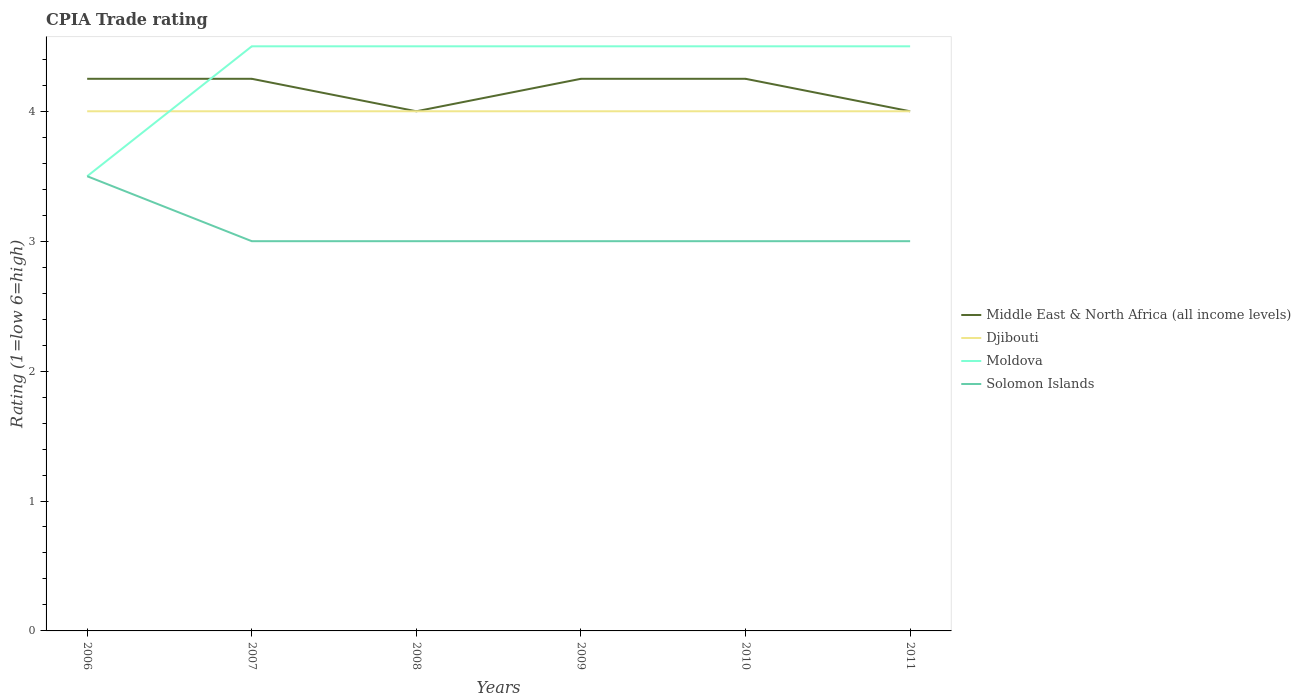Is the number of lines equal to the number of legend labels?
Offer a very short reply. Yes. In which year was the CPIA rating in Moldova maximum?
Provide a short and direct response. 2006. What is the difference between the highest and the second highest CPIA rating in Solomon Islands?
Your answer should be very brief. 0.5. Is the CPIA rating in Moldova strictly greater than the CPIA rating in Djibouti over the years?
Keep it short and to the point. No. Does the graph contain any zero values?
Provide a short and direct response. No. How many legend labels are there?
Give a very brief answer. 4. What is the title of the graph?
Make the answer very short. CPIA Trade rating. Does "European Union" appear as one of the legend labels in the graph?
Provide a short and direct response. No. What is the label or title of the X-axis?
Make the answer very short. Years. What is the Rating (1=low 6=high) in Middle East & North Africa (all income levels) in 2006?
Give a very brief answer. 4.25. What is the Rating (1=low 6=high) of Moldova in 2006?
Provide a succinct answer. 3.5. What is the Rating (1=low 6=high) in Solomon Islands in 2006?
Ensure brevity in your answer.  3.5. What is the Rating (1=low 6=high) in Middle East & North Africa (all income levels) in 2007?
Give a very brief answer. 4.25. What is the Rating (1=low 6=high) of Djibouti in 2007?
Give a very brief answer. 4. What is the Rating (1=low 6=high) in Middle East & North Africa (all income levels) in 2008?
Ensure brevity in your answer.  4. What is the Rating (1=low 6=high) in Middle East & North Africa (all income levels) in 2009?
Ensure brevity in your answer.  4.25. What is the Rating (1=low 6=high) in Djibouti in 2009?
Give a very brief answer. 4. What is the Rating (1=low 6=high) of Middle East & North Africa (all income levels) in 2010?
Provide a succinct answer. 4.25. What is the Rating (1=low 6=high) in Solomon Islands in 2010?
Offer a very short reply. 3. What is the Rating (1=low 6=high) in Djibouti in 2011?
Make the answer very short. 4. Across all years, what is the maximum Rating (1=low 6=high) in Middle East & North Africa (all income levels)?
Offer a terse response. 4.25. Across all years, what is the maximum Rating (1=low 6=high) in Solomon Islands?
Offer a terse response. 3.5. Across all years, what is the minimum Rating (1=low 6=high) of Middle East & North Africa (all income levels)?
Make the answer very short. 4. Across all years, what is the minimum Rating (1=low 6=high) in Djibouti?
Make the answer very short. 4. Across all years, what is the minimum Rating (1=low 6=high) in Moldova?
Ensure brevity in your answer.  3.5. What is the total Rating (1=low 6=high) in Middle East & North Africa (all income levels) in the graph?
Offer a very short reply. 25. What is the total Rating (1=low 6=high) in Moldova in the graph?
Your answer should be compact. 26. What is the total Rating (1=low 6=high) of Solomon Islands in the graph?
Your response must be concise. 18.5. What is the difference between the Rating (1=low 6=high) of Djibouti in 2006 and that in 2007?
Your answer should be compact. 0. What is the difference between the Rating (1=low 6=high) in Moldova in 2006 and that in 2007?
Make the answer very short. -1. What is the difference between the Rating (1=low 6=high) of Solomon Islands in 2006 and that in 2007?
Your answer should be very brief. 0.5. What is the difference between the Rating (1=low 6=high) of Middle East & North Africa (all income levels) in 2006 and that in 2008?
Your answer should be very brief. 0.25. What is the difference between the Rating (1=low 6=high) in Djibouti in 2006 and that in 2008?
Your response must be concise. 0. What is the difference between the Rating (1=low 6=high) of Moldova in 2006 and that in 2008?
Ensure brevity in your answer.  -1. What is the difference between the Rating (1=low 6=high) of Solomon Islands in 2006 and that in 2009?
Offer a very short reply. 0.5. What is the difference between the Rating (1=low 6=high) of Moldova in 2006 and that in 2010?
Your response must be concise. -1. What is the difference between the Rating (1=low 6=high) of Solomon Islands in 2006 and that in 2010?
Offer a terse response. 0.5. What is the difference between the Rating (1=low 6=high) in Moldova in 2006 and that in 2011?
Ensure brevity in your answer.  -1. What is the difference between the Rating (1=low 6=high) of Solomon Islands in 2006 and that in 2011?
Make the answer very short. 0.5. What is the difference between the Rating (1=low 6=high) in Middle East & North Africa (all income levels) in 2007 and that in 2008?
Keep it short and to the point. 0.25. What is the difference between the Rating (1=low 6=high) in Djibouti in 2007 and that in 2008?
Offer a terse response. 0. What is the difference between the Rating (1=low 6=high) of Moldova in 2007 and that in 2008?
Ensure brevity in your answer.  0. What is the difference between the Rating (1=low 6=high) of Middle East & North Africa (all income levels) in 2007 and that in 2009?
Give a very brief answer. 0. What is the difference between the Rating (1=low 6=high) of Djibouti in 2007 and that in 2009?
Your answer should be compact. 0. What is the difference between the Rating (1=low 6=high) in Middle East & North Africa (all income levels) in 2007 and that in 2010?
Your answer should be very brief. 0. What is the difference between the Rating (1=low 6=high) of Djibouti in 2007 and that in 2010?
Offer a very short reply. 0. What is the difference between the Rating (1=low 6=high) of Djibouti in 2007 and that in 2011?
Your answer should be very brief. 0. What is the difference between the Rating (1=low 6=high) of Moldova in 2007 and that in 2011?
Your answer should be compact. 0. What is the difference between the Rating (1=low 6=high) of Solomon Islands in 2007 and that in 2011?
Your answer should be very brief. 0. What is the difference between the Rating (1=low 6=high) in Middle East & North Africa (all income levels) in 2008 and that in 2009?
Your response must be concise. -0.25. What is the difference between the Rating (1=low 6=high) in Moldova in 2008 and that in 2009?
Offer a very short reply. 0. What is the difference between the Rating (1=low 6=high) in Middle East & North Africa (all income levels) in 2008 and that in 2010?
Your answer should be very brief. -0.25. What is the difference between the Rating (1=low 6=high) in Djibouti in 2008 and that in 2010?
Ensure brevity in your answer.  0. What is the difference between the Rating (1=low 6=high) of Moldova in 2008 and that in 2010?
Provide a short and direct response. 0. What is the difference between the Rating (1=low 6=high) of Solomon Islands in 2008 and that in 2010?
Your answer should be compact. 0. What is the difference between the Rating (1=low 6=high) in Middle East & North Africa (all income levels) in 2008 and that in 2011?
Keep it short and to the point. 0. What is the difference between the Rating (1=low 6=high) in Solomon Islands in 2008 and that in 2011?
Offer a terse response. 0. What is the difference between the Rating (1=low 6=high) in Middle East & North Africa (all income levels) in 2009 and that in 2010?
Give a very brief answer. 0. What is the difference between the Rating (1=low 6=high) in Moldova in 2009 and that in 2010?
Give a very brief answer. 0. What is the difference between the Rating (1=low 6=high) in Solomon Islands in 2009 and that in 2010?
Your answer should be very brief. 0. What is the difference between the Rating (1=low 6=high) in Middle East & North Africa (all income levels) in 2009 and that in 2011?
Your answer should be very brief. 0.25. What is the difference between the Rating (1=low 6=high) of Djibouti in 2009 and that in 2011?
Provide a succinct answer. 0. What is the difference between the Rating (1=low 6=high) of Moldova in 2009 and that in 2011?
Offer a terse response. 0. What is the difference between the Rating (1=low 6=high) of Solomon Islands in 2010 and that in 2011?
Give a very brief answer. 0. What is the difference between the Rating (1=low 6=high) of Middle East & North Africa (all income levels) in 2006 and the Rating (1=low 6=high) of Djibouti in 2007?
Provide a short and direct response. 0.25. What is the difference between the Rating (1=low 6=high) in Middle East & North Africa (all income levels) in 2006 and the Rating (1=low 6=high) in Solomon Islands in 2007?
Give a very brief answer. 1.25. What is the difference between the Rating (1=low 6=high) in Moldova in 2006 and the Rating (1=low 6=high) in Solomon Islands in 2007?
Offer a terse response. 0.5. What is the difference between the Rating (1=low 6=high) in Middle East & North Africa (all income levels) in 2006 and the Rating (1=low 6=high) in Moldova in 2008?
Provide a succinct answer. -0.25. What is the difference between the Rating (1=low 6=high) in Middle East & North Africa (all income levels) in 2006 and the Rating (1=low 6=high) in Solomon Islands in 2008?
Provide a short and direct response. 1.25. What is the difference between the Rating (1=low 6=high) in Moldova in 2006 and the Rating (1=low 6=high) in Solomon Islands in 2008?
Your response must be concise. 0.5. What is the difference between the Rating (1=low 6=high) in Djibouti in 2006 and the Rating (1=low 6=high) in Moldova in 2009?
Offer a very short reply. -0.5. What is the difference between the Rating (1=low 6=high) in Middle East & North Africa (all income levels) in 2006 and the Rating (1=low 6=high) in Djibouti in 2010?
Offer a very short reply. 0.25. What is the difference between the Rating (1=low 6=high) of Djibouti in 2006 and the Rating (1=low 6=high) of Moldova in 2010?
Ensure brevity in your answer.  -0.5. What is the difference between the Rating (1=low 6=high) in Moldova in 2006 and the Rating (1=low 6=high) in Solomon Islands in 2010?
Make the answer very short. 0.5. What is the difference between the Rating (1=low 6=high) of Middle East & North Africa (all income levels) in 2006 and the Rating (1=low 6=high) of Djibouti in 2011?
Your answer should be compact. 0.25. What is the difference between the Rating (1=low 6=high) in Djibouti in 2006 and the Rating (1=low 6=high) in Moldova in 2011?
Offer a very short reply. -0.5. What is the difference between the Rating (1=low 6=high) in Djibouti in 2006 and the Rating (1=low 6=high) in Solomon Islands in 2011?
Provide a succinct answer. 1. What is the difference between the Rating (1=low 6=high) of Moldova in 2006 and the Rating (1=low 6=high) of Solomon Islands in 2011?
Give a very brief answer. 0.5. What is the difference between the Rating (1=low 6=high) of Middle East & North Africa (all income levels) in 2007 and the Rating (1=low 6=high) of Solomon Islands in 2009?
Your answer should be compact. 1.25. What is the difference between the Rating (1=low 6=high) of Djibouti in 2007 and the Rating (1=low 6=high) of Solomon Islands in 2009?
Keep it short and to the point. 1. What is the difference between the Rating (1=low 6=high) of Middle East & North Africa (all income levels) in 2007 and the Rating (1=low 6=high) of Djibouti in 2010?
Give a very brief answer. 0.25. What is the difference between the Rating (1=low 6=high) in Middle East & North Africa (all income levels) in 2007 and the Rating (1=low 6=high) in Solomon Islands in 2010?
Provide a short and direct response. 1.25. What is the difference between the Rating (1=low 6=high) in Djibouti in 2007 and the Rating (1=low 6=high) in Moldova in 2010?
Provide a short and direct response. -0.5. What is the difference between the Rating (1=low 6=high) in Moldova in 2007 and the Rating (1=low 6=high) in Solomon Islands in 2010?
Your answer should be compact. 1.5. What is the difference between the Rating (1=low 6=high) of Djibouti in 2007 and the Rating (1=low 6=high) of Solomon Islands in 2011?
Offer a terse response. 1. What is the difference between the Rating (1=low 6=high) of Moldova in 2007 and the Rating (1=low 6=high) of Solomon Islands in 2011?
Provide a short and direct response. 1.5. What is the difference between the Rating (1=low 6=high) in Middle East & North Africa (all income levels) in 2008 and the Rating (1=low 6=high) in Moldova in 2009?
Give a very brief answer. -0.5. What is the difference between the Rating (1=low 6=high) in Moldova in 2008 and the Rating (1=low 6=high) in Solomon Islands in 2009?
Make the answer very short. 1.5. What is the difference between the Rating (1=low 6=high) in Middle East & North Africa (all income levels) in 2008 and the Rating (1=low 6=high) in Moldova in 2010?
Offer a terse response. -0.5. What is the difference between the Rating (1=low 6=high) in Middle East & North Africa (all income levels) in 2008 and the Rating (1=low 6=high) in Solomon Islands in 2010?
Your answer should be compact. 1. What is the difference between the Rating (1=low 6=high) of Djibouti in 2008 and the Rating (1=low 6=high) of Moldova in 2010?
Make the answer very short. -0.5. What is the difference between the Rating (1=low 6=high) of Djibouti in 2008 and the Rating (1=low 6=high) of Solomon Islands in 2010?
Your answer should be very brief. 1. What is the difference between the Rating (1=low 6=high) in Moldova in 2008 and the Rating (1=low 6=high) in Solomon Islands in 2010?
Your response must be concise. 1.5. What is the difference between the Rating (1=low 6=high) in Djibouti in 2008 and the Rating (1=low 6=high) in Moldova in 2011?
Your response must be concise. -0.5. What is the difference between the Rating (1=low 6=high) in Djibouti in 2008 and the Rating (1=low 6=high) in Solomon Islands in 2011?
Give a very brief answer. 1. What is the difference between the Rating (1=low 6=high) in Middle East & North Africa (all income levels) in 2009 and the Rating (1=low 6=high) in Djibouti in 2010?
Give a very brief answer. 0.25. What is the difference between the Rating (1=low 6=high) in Middle East & North Africa (all income levels) in 2009 and the Rating (1=low 6=high) in Solomon Islands in 2010?
Offer a very short reply. 1.25. What is the difference between the Rating (1=low 6=high) in Middle East & North Africa (all income levels) in 2009 and the Rating (1=low 6=high) in Moldova in 2011?
Your answer should be very brief. -0.25. What is the difference between the Rating (1=low 6=high) of Moldova in 2009 and the Rating (1=low 6=high) of Solomon Islands in 2011?
Give a very brief answer. 1.5. What is the difference between the Rating (1=low 6=high) in Middle East & North Africa (all income levels) in 2010 and the Rating (1=low 6=high) in Moldova in 2011?
Give a very brief answer. -0.25. What is the difference between the Rating (1=low 6=high) in Moldova in 2010 and the Rating (1=low 6=high) in Solomon Islands in 2011?
Make the answer very short. 1.5. What is the average Rating (1=low 6=high) in Middle East & North Africa (all income levels) per year?
Make the answer very short. 4.17. What is the average Rating (1=low 6=high) of Moldova per year?
Give a very brief answer. 4.33. What is the average Rating (1=low 6=high) of Solomon Islands per year?
Provide a short and direct response. 3.08. In the year 2006, what is the difference between the Rating (1=low 6=high) of Middle East & North Africa (all income levels) and Rating (1=low 6=high) of Djibouti?
Give a very brief answer. 0.25. In the year 2006, what is the difference between the Rating (1=low 6=high) in Djibouti and Rating (1=low 6=high) in Solomon Islands?
Keep it short and to the point. 0.5. In the year 2006, what is the difference between the Rating (1=low 6=high) in Moldova and Rating (1=low 6=high) in Solomon Islands?
Keep it short and to the point. 0. In the year 2007, what is the difference between the Rating (1=low 6=high) in Middle East & North Africa (all income levels) and Rating (1=low 6=high) in Djibouti?
Keep it short and to the point. 0.25. In the year 2007, what is the difference between the Rating (1=low 6=high) in Djibouti and Rating (1=low 6=high) in Solomon Islands?
Give a very brief answer. 1. In the year 2008, what is the difference between the Rating (1=low 6=high) in Djibouti and Rating (1=low 6=high) in Moldova?
Make the answer very short. -0.5. In the year 2009, what is the difference between the Rating (1=low 6=high) of Djibouti and Rating (1=low 6=high) of Solomon Islands?
Make the answer very short. 1. In the year 2010, what is the difference between the Rating (1=low 6=high) of Middle East & North Africa (all income levels) and Rating (1=low 6=high) of Moldova?
Offer a very short reply. -0.25. In the year 2010, what is the difference between the Rating (1=low 6=high) of Middle East & North Africa (all income levels) and Rating (1=low 6=high) of Solomon Islands?
Offer a terse response. 1.25. In the year 2010, what is the difference between the Rating (1=low 6=high) of Moldova and Rating (1=low 6=high) of Solomon Islands?
Provide a short and direct response. 1.5. In the year 2011, what is the difference between the Rating (1=low 6=high) in Middle East & North Africa (all income levels) and Rating (1=low 6=high) in Djibouti?
Your response must be concise. 0. In the year 2011, what is the difference between the Rating (1=low 6=high) in Middle East & North Africa (all income levels) and Rating (1=low 6=high) in Moldova?
Provide a short and direct response. -0.5. In the year 2011, what is the difference between the Rating (1=low 6=high) in Djibouti and Rating (1=low 6=high) in Moldova?
Give a very brief answer. -0.5. In the year 2011, what is the difference between the Rating (1=low 6=high) of Moldova and Rating (1=low 6=high) of Solomon Islands?
Offer a very short reply. 1.5. What is the ratio of the Rating (1=low 6=high) of Middle East & North Africa (all income levels) in 2006 to that in 2007?
Make the answer very short. 1. What is the ratio of the Rating (1=low 6=high) of Djibouti in 2006 to that in 2007?
Keep it short and to the point. 1. What is the ratio of the Rating (1=low 6=high) of Solomon Islands in 2006 to that in 2007?
Your answer should be very brief. 1.17. What is the ratio of the Rating (1=low 6=high) in Middle East & North Africa (all income levels) in 2006 to that in 2008?
Provide a succinct answer. 1.06. What is the ratio of the Rating (1=low 6=high) in Moldova in 2006 to that in 2008?
Offer a very short reply. 0.78. What is the ratio of the Rating (1=low 6=high) of Middle East & North Africa (all income levels) in 2006 to that in 2009?
Offer a terse response. 1. What is the ratio of the Rating (1=low 6=high) in Djibouti in 2006 to that in 2009?
Provide a succinct answer. 1. What is the ratio of the Rating (1=low 6=high) in Moldova in 2006 to that in 2009?
Give a very brief answer. 0.78. What is the ratio of the Rating (1=low 6=high) in Middle East & North Africa (all income levels) in 2006 to that in 2010?
Your answer should be compact. 1. What is the ratio of the Rating (1=low 6=high) of Middle East & North Africa (all income levels) in 2006 to that in 2011?
Your answer should be compact. 1.06. What is the ratio of the Rating (1=low 6=high) of Moldova in 2006 to that in 2011?
Give a very brief answer. 0.78. What is the ratio of the Rating (1=low 6=high) of Middle East & North Africa (all income levels) in 2007 to that in 2008?
Give a very brief answer. 1.06. What is the ratio of the Rating (1=low 6=high) in Moldova in 2007 to that in 2008?
Offer a terse response. 1. What is the ratio of the Rating (1=low 6=high) in Solomon Islands in 2007 to that in 2008?
Keep it short and to the point. 1. What is the ratio of the Rating (1=low 6=high) of Middle East & North Africa (all income levels) in 2007 to that in 2009?
Your answer should be very brief. 1. What is the ratio of the Rating (1=low 6=high) in Solomon Islands in 2007 to that in 2009?
Provide a succinct answer. 1. What is the ratio of the Rating (1=low 6=high) of Middle East & North Africa (all income levels) in 2007 to that in 2010?
Provide a succinct answer. 1. What is the ratio of the Rating (1=low 6=high) in Djibouti in 2007 to that in 2010?
Offer a very short reply. 1. What is the ratio of the Rating (1=low 6=high) in Moldova in 2007 to that in 2010?
Provide a short and direct response. 1. What is the ratio of the Rating (1=low 6=high) of Middle East & North Africa (all income levels) in 2007 to that in 2011?
Give a very brief answer. 1.06. What is the ratio of the Rating (1=low 6=high) of Moldova in 2007 to that in 2011?
Offer a very short reply. 1. What is the ratio of the Rating (1=low 6=high) of Solomon Islands in 2007 to that in 2011?
Give a very brief answer. 1. What is the ratio of the Rating (1=low 6=high) in Djibouti in 2008 to that in 2009?
Your response must be concise. 1. What is the ratio of the Rating (1=low 6=high) in Middle East & North Africa (all income levels) in 2008 to that in 2010?
Provide a succinct answer. 0.94. What is the ratio of the Rating (1=low 6=high) in Djibouti in 2008 to that in 2010?
Offer a terse response. 1. What is the ratio of the Rating (1=low 6=high) in Solomon Islands in 2008 to that in 2010?
Make the answer very short. 1. What is the ratio of the Rating (1=low 6=high) in Middle East & North Africa (all income levels) in 2008 to that in 2011?
Your answer should be compact. 1. What is the ratio of the Rating (1=low 6=high) of Djibouti in 2008 to that in 2011?
Ensure brevity in your answer.  1. What is the ratio of the Rating (1=low 6=high) of Moldova in 2008 to that in 2011?
Ensure brevity in your answer.  1. What is the ratio of the Rating (1=low 6=high) in Djibouti in 2009 to that in 2010?
Make the answer very short. 1. What is the ratio of the Rating (1=low 6=high) in Middle East & North Africa (all income levels) in 2009 to that in 2011?
Keep it short and to the point. 1.06. What is the ratio of the Rating (1=low 6=high) of Djibouti in 2009 to that in 2011?
Your response must be concise. 1. What is the ratio of the Rating (1=low 6=high) in Moldova in 2009 to that in 2011?
Keep it short and to the point. 1. What is the ratio of the Rating (1=low 6=high) of Solomon Islands in 2009 to that in 2011?
Ensure brevity in your answer.  1. What is the ratio of the Rating (1=low 6=high) of Djibouti in 2010 to that in 2011?
Provide a succinct answer. 1. What is the ratio of the Rating (1=low 6=high) of Moldova in 2010 to that in 2011?
Keep it short and to the point. 1. What is the difference between the highest and the second highest Rating (1=low 6=high) of Middle East & North Africa (all income levels)?
Your answer should be very brief. 0. What is the difference between the highest and the second highest Rating (1=low 6=high) of Djibouti?
Make the answer very short. 0. What is the difference between the highest and the second highest Rating (1=low 6=high) of Solomon Islands?
Your response must be concise. 0.5. What is the difference between the highest and the lowest Rating (1=low 6=high) in Middle East & North Africa (all income levels)?
Ensure brevity in your answer.  0.25. What is the difference between the highest and the lowest Rating (1=low 6=high) of Djibouti?
Provide a short and direct response. 0. What is the difference between the highest and the lowest Rating (1=low 6=high) in Solomon Islands?
Keep it short and to the point. 0.5. 